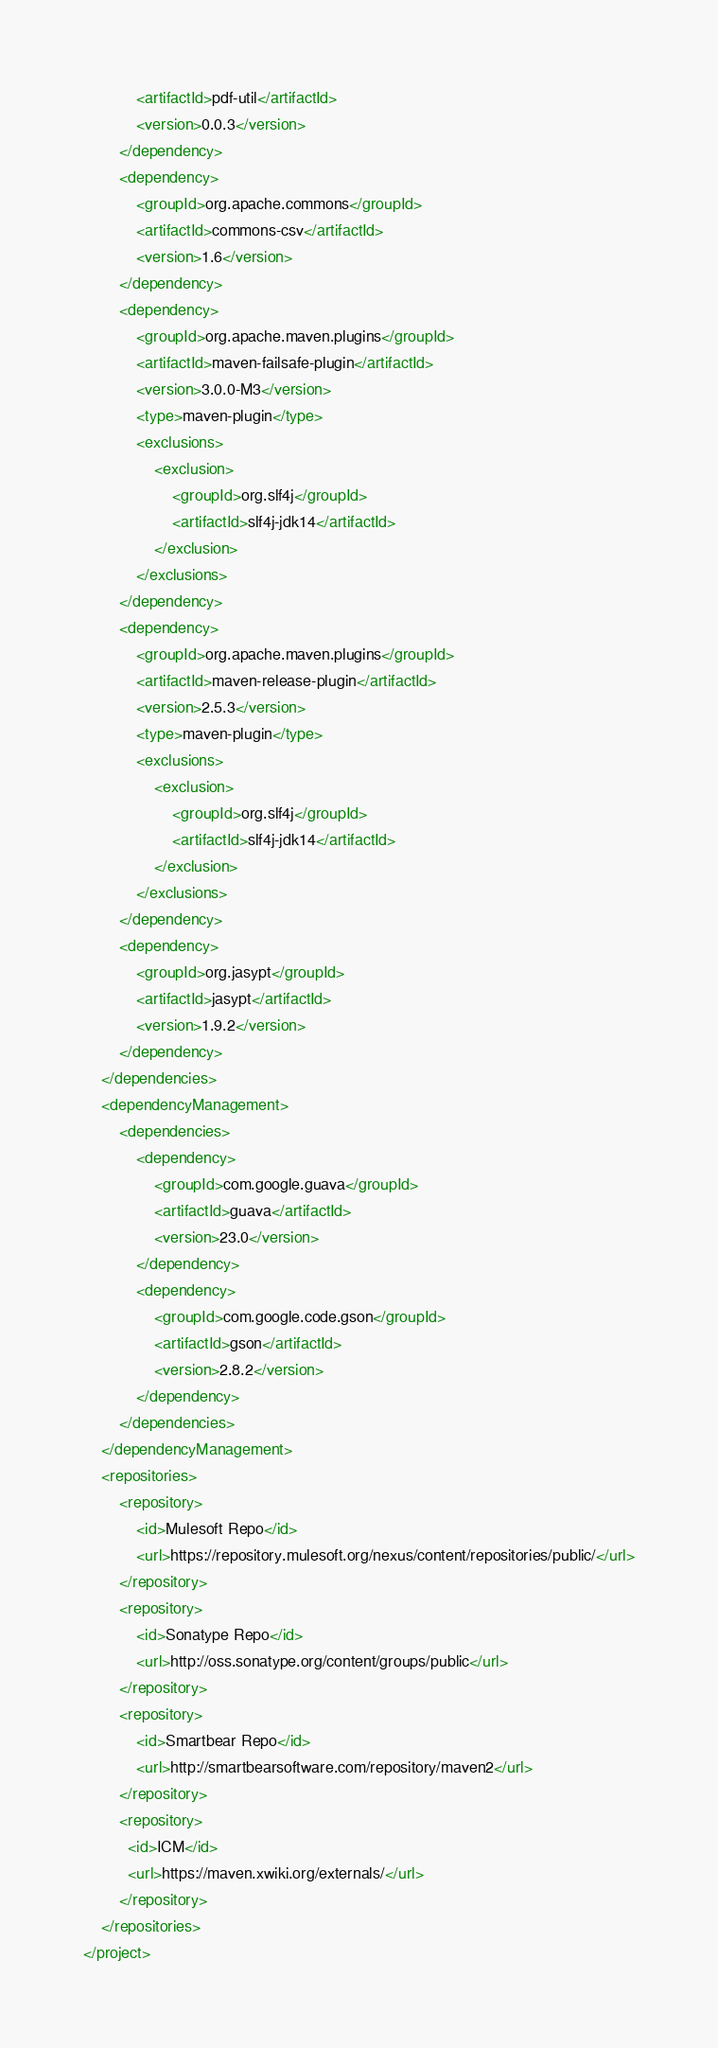<code> <loc_0><loc_0><loc_500><loc_500><_XML_>            <artifactId>pdf-util</artifactId>
            <version>0.0.3</version>
        </dependency>
        <dependency>
            <groupId>org.apache.commons</groupId>
            <artifactId>commons-csv</artifactId>
            <version>1.6</version>
        </dependency>
        <dependency>
            <groupId>org.apache.maven.plugins</groupId>
            <artifactId>maven-failsafe-plugin</artifactId>
            <version>3.0.0-M3</version>
            <type>maven-plugin</type>
            <exclusions>
                <exclusion>
                    <groupId>org.slf4j</groupId>
                    <artifactId>slf4j-jdk14</artifactId>
                </exclusion>
            </exclusions>
        </dependency>
        <dependency>
            <groupId>org.apache.maven.plugins</groupId>
            <artifactId>maven-release-plugin</artifactId>
            <version>2.5.3</version>
            <type>maven-plugin</type>
            <exclusions>
                <exclusion>
                    <groupId>org.slf4j</groupId>
                    <artifactId>slf4j-jdk14</artifactId>
                </exclusion>
            </exclusions>
        </dependency>
        <dependency>
            <groupId>org.jasypt</groupId>
            <artifactId>jasypt</artifactId>
            <version>1.9.2</version>
        </dependency>
    </dependencies>
    <dependencyManagement>
        <dependencies>
            <dependency>
                <groupId>com.google.guava</groupId>
                <artifactId>guava</artifactId>
                <version>23.0</version>
            </dependency>
            <dependency>
                <groupId>com.google.code.gson</groupId>
                <artifactId>gson</artifactId>
                <version>2.8.2</version>
            </dependency>
        </dependencies>
    </dependencyManagement>
    <repositories>
        <repository>
            <id>Mulesoft Repo</id>
            <url>https://repository.mulesoft.org/nexus/content/repositories/public/</url>
        </repository>
        <repository>
            <id>Sonatype Repo</id>
            <url>http://oss.sonatype.org/content/groups/public</url>
        </repository>
        <repository>
            <id>Smartbear Repo</id>
            <url>http://smartbearsoftware.com/repository/maven2</url>
        </repository>
        <repository>
    	  <id>ICM</id>
    	  <url>https://maven.xwiki.org/externals/</url>
    	</repository>
    </repositories>
</project>
</code> 